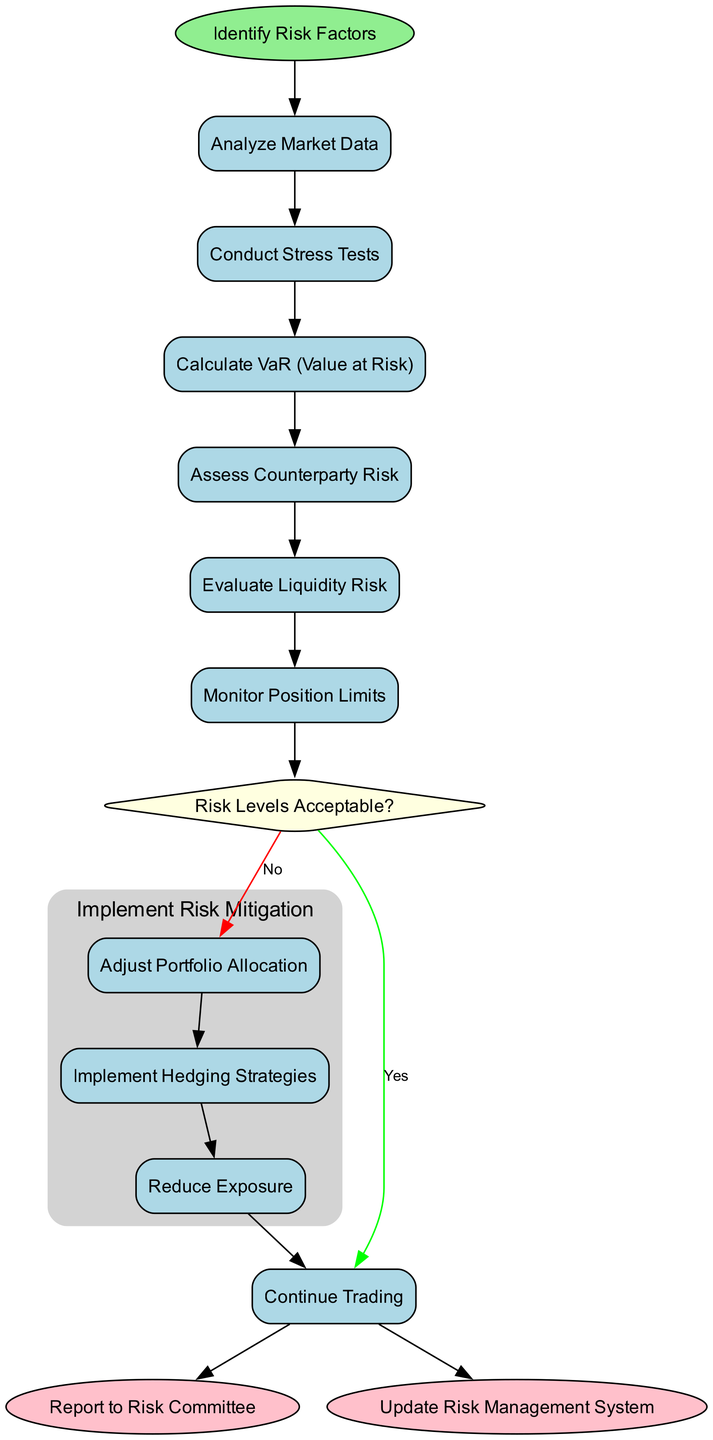What is the starting point of the workflow? The diagram indicates that the workflow begins with the node labeled "Identify Risk Factors." This is the designated start node that initiates the entire risk management process.
Answer: Identify Risk Factors How many activities are in the workflow? The diagram lists six distinct activities involved in the risk management workflow, showing how various risk factors are addressed.
Answer: Six What is the first activity after identifying risk factors? The first activity following "Identify Risk Factors" is "Analyze Market Data," as it is directly connected to the start node and reflects the first step in the workflow after initiation.
Answer: Analyze Market Data What happens if the risk levels are acceptable? If the condition of risk levels being acceptable is satisfied (the "Yes" path in the decision node), the workflow leads to the node labeled "Continue Trading," indicating that operations proceed as normal.
Answer: Continue Trading What is the subprocess defined in the diagram? The subprocess defined in the diagram is named "Implement Risk Mitigation," which encompasses three specific activities focused on addressing risk if levels are found to be unacceptable.
Answer: Implement Risk Mitigation What are the activities included in the subprocess? The activities within the subprocess of "Implement Risk Mitigation" are "Adjust Portfolio Allocation," "Implement Hedging Strategies," and "Reduce Exposure," each intended to reduce risk exposure.
Answer: Adjust Portfolio Allocation, Implement Hedging Strategies, Reduce Exposure What occurs if the risk levels are not acceptable? If the risk levels are deemed not acceptable, as indicated on the "No" branch from the decision node, the workflow leads to the subprocess of "Implement Risk Mitigation," where specific actions are taken to mitigate risks.
Answer: Implement Risk Mitigation What are the end nodes of the workflow? The workflow concludes with two end nodes: "Report to Risk Committee" and "Update Risk Management System," representing the final steps before the workflow ends.
Answer: Report to Risk Committee, Update Risk Management System How many edges are used in the diagram? The diagram depicts four edges, which represent connections and transitions between various nodes throughout the workflow, facilitating the flow of process steps.
Answer: Four 